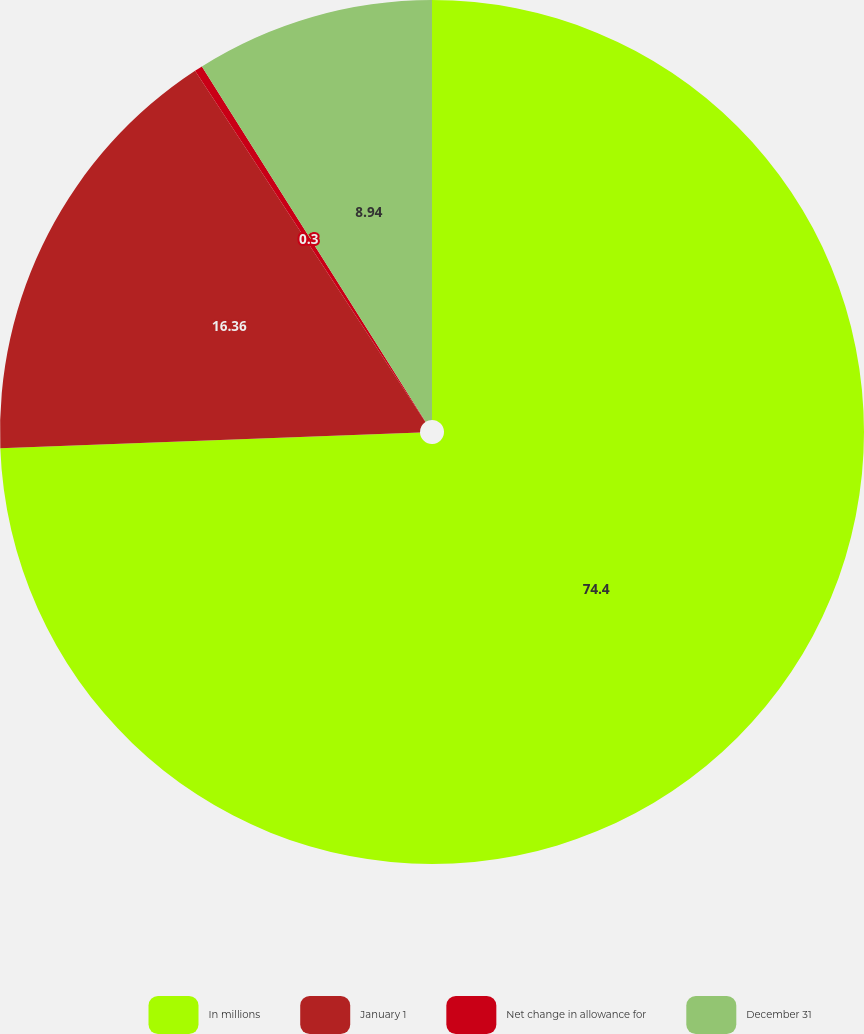Convert chart to OTSL. <chart><loc_0><loc_0><loc_500><loc_500><pie_chart><fcel>In millions<fcel>January 1<fcel>Net change in allowance for<fcel>December 31<nl><fcel>74.4%<fcel>16.36%<fcel>0.3%<fcel>8.94%<nl></chart> 